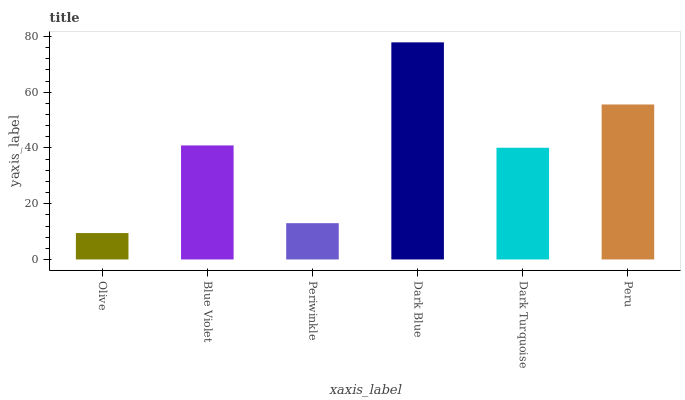Is Olive the minimum?
Answer yes or no. Yes. Is Dark Blue the maximum?
Answer yes or no. Yes. Is Blue Violet the minimum?
Answer yes or no. No. Is Blue Violet the maximum?
Answer yes or no. No. Is Blue Violet greater than Olive?
Answer yes or no. Yes. Is Olive less than Blue Violet?
Answer yes or no. Yes. Is Olive greater than Blue Violet?
Answer yes or no. No. Is Blue Violet less than Olive?
Answer yes or no. No. Is Blue Violet the high median?
Answer yes or no. Yes. Is Dark Turquoise the low median?
Answer yes or no. Yes. Is Dark Blue the high median?
Answer yes or no. No. Is Olive the low median?
Answer yes or no. No. 